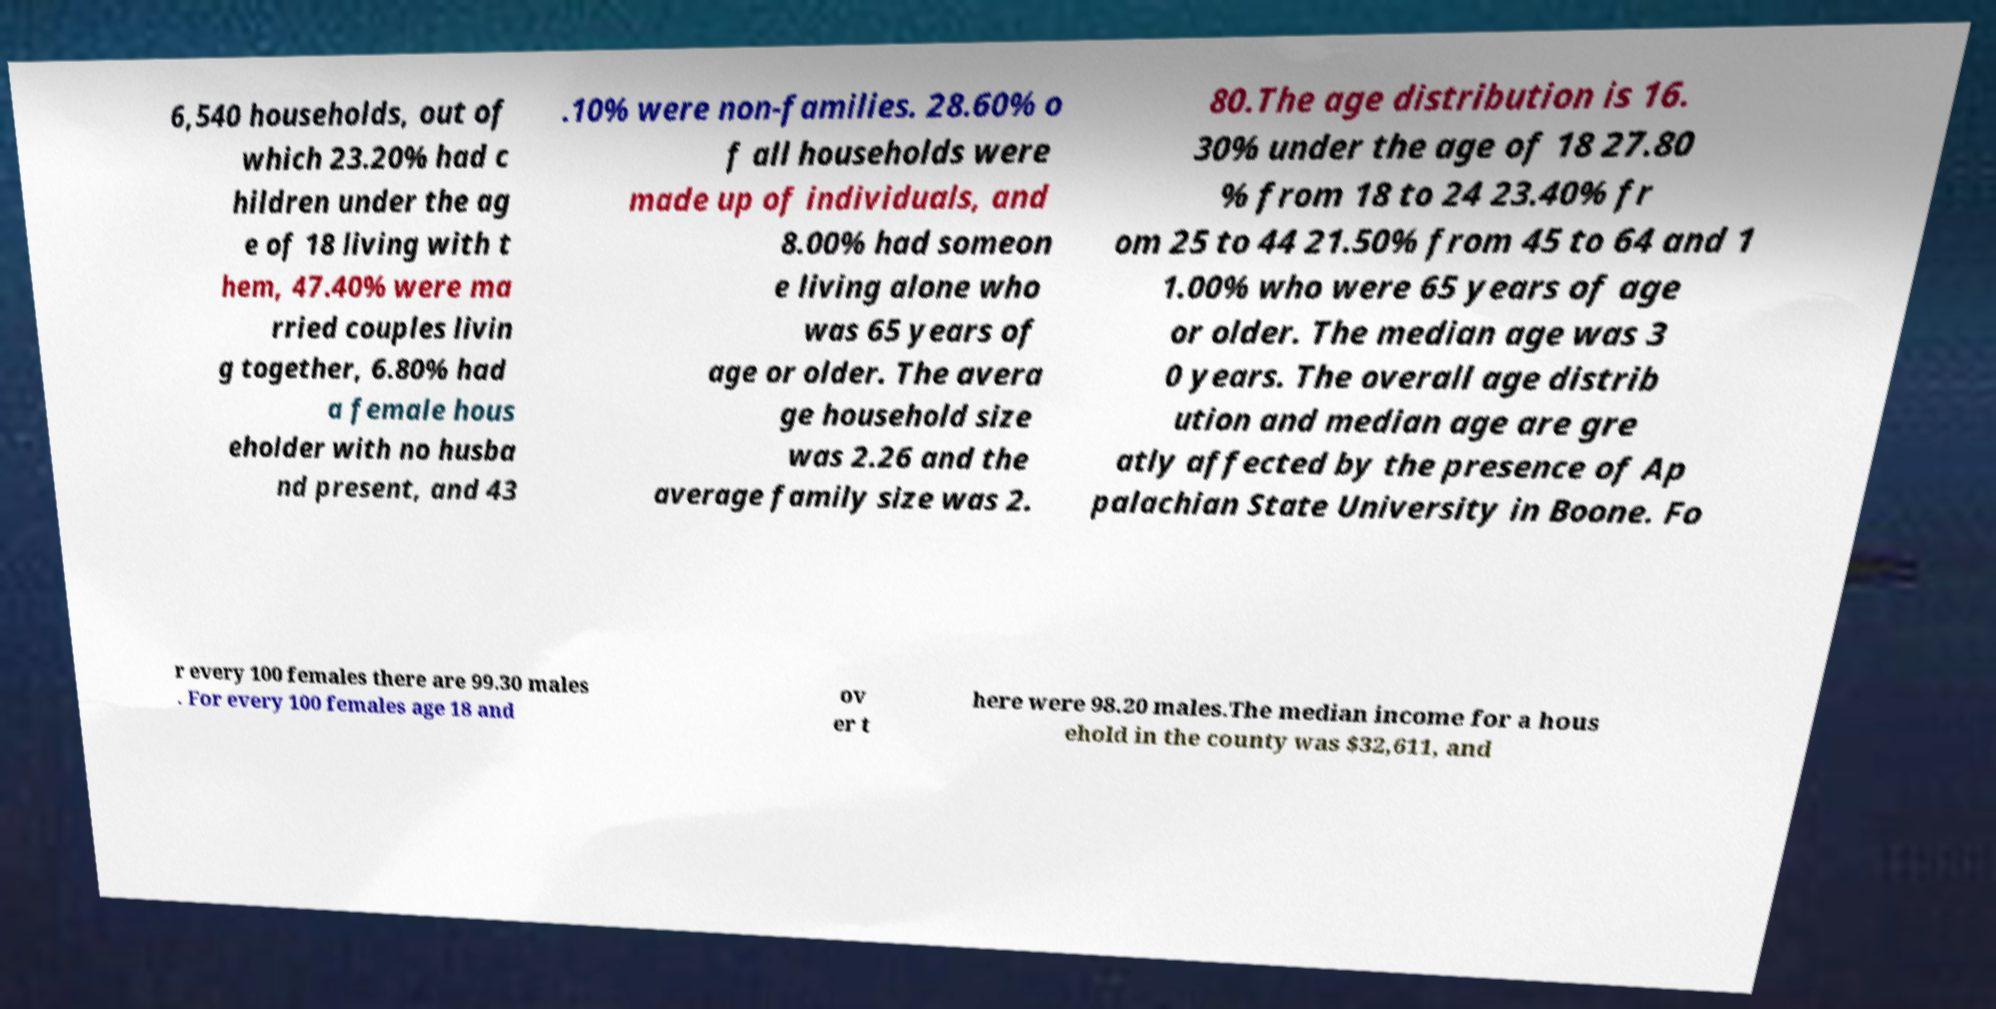Please read and relay the text visible in this image. What does it say? 6,540 households, out of which 23.20% had c hildren under the ag e of 18 living with t hem, 47.40% were ma rried couples livin g together, 6.80% had a female hous eholder with no husba nd present, and 43 .10% were non-families. 28.60% o f all households were made up of individuals, and 8.00% had someon e living alone who was 65 years of age or older. The avera ge household size was 2.26 and the average family size was 2. 80.The age distribution is 16. 30% under the age of 18 27.80 % from 18 to 24 23.40% fr om 25 to 44 21.50% from 45 to 64 and 1 1.00% who were 65 years of age or older. The median age was 3 0 years. The overall age distrib ution and median age are gre atly affected by the presence of Ap palachian State University in Boone. Fo r every 100 females there are 99.30 males . For every 100 females age 18 and ov er t here were 98.20 males.The median income for a hous ehold in the county was $32,611, and 